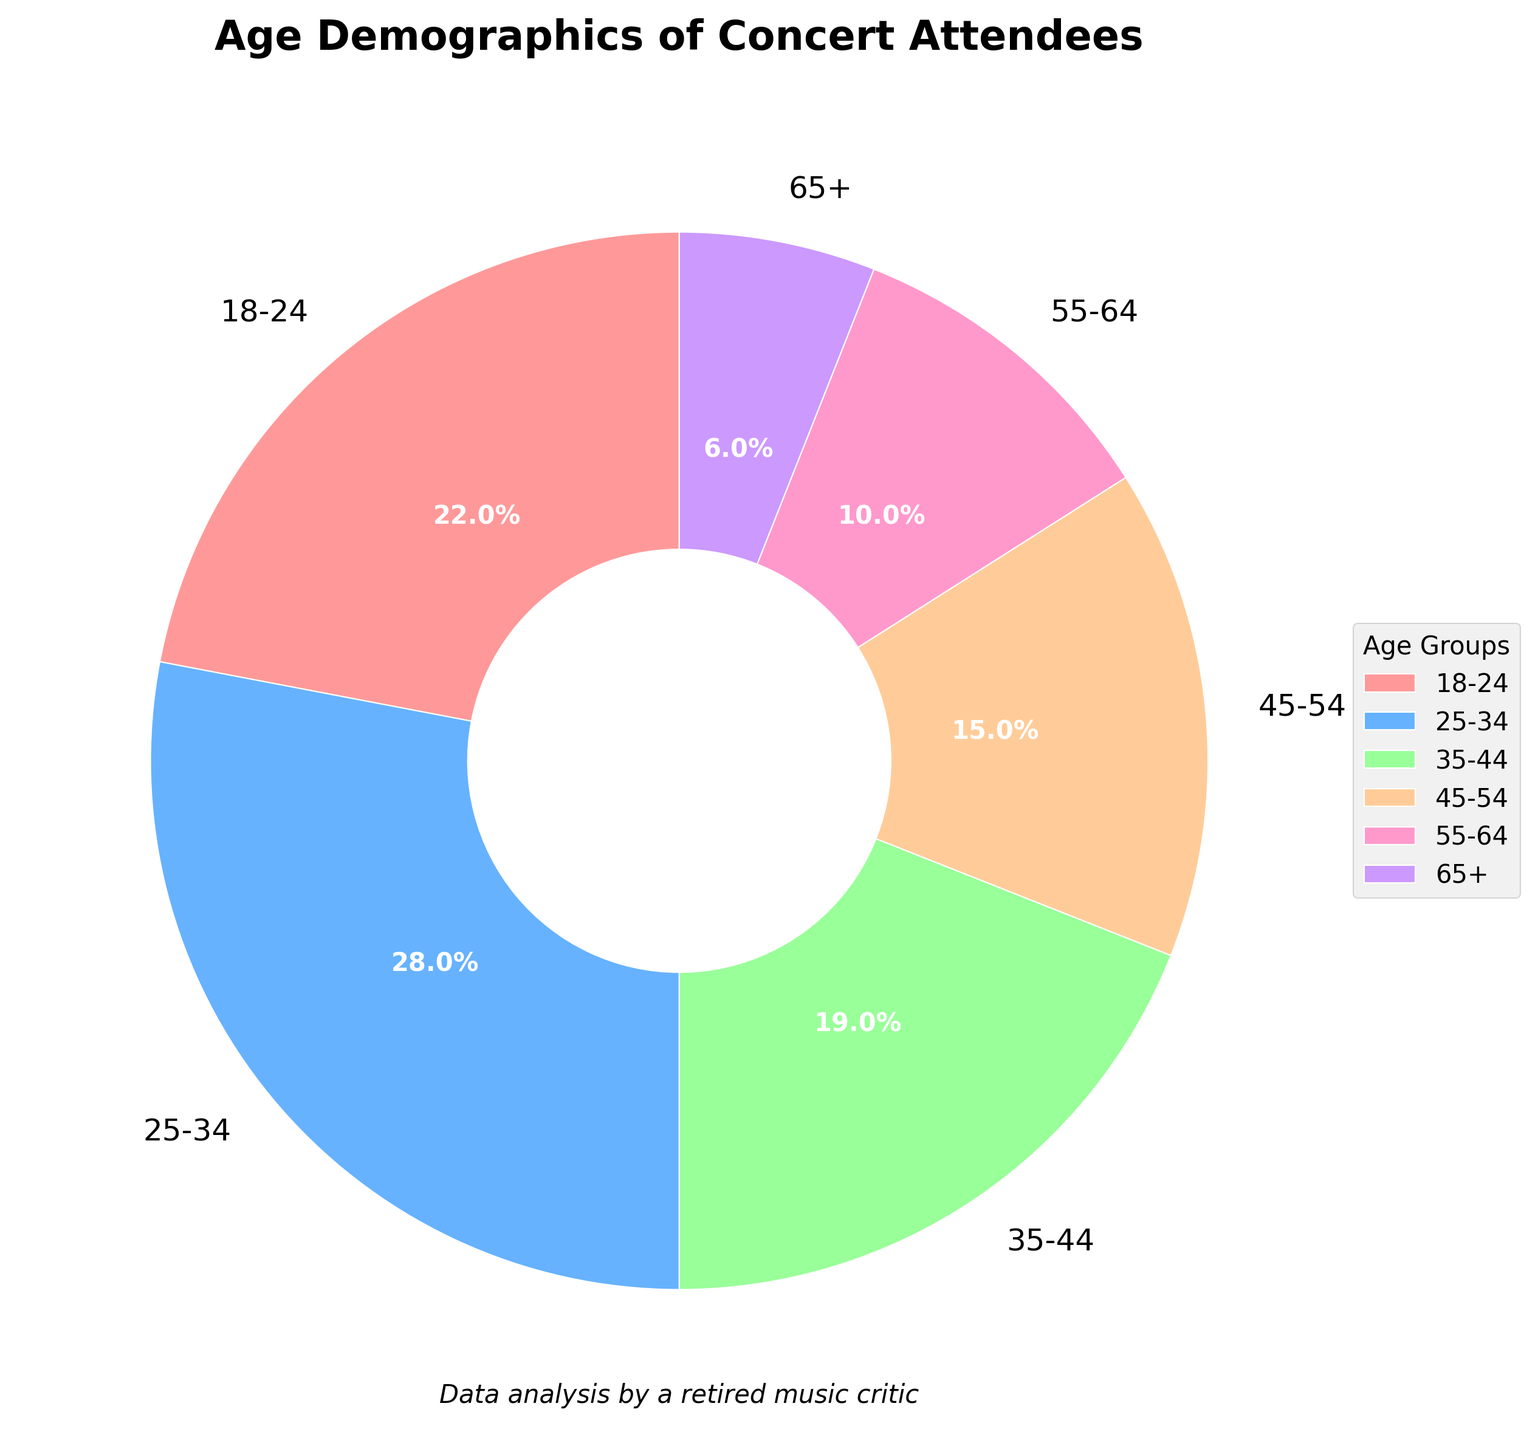Which age group has the highest percentage of concert attendees? The pie chart shows different age groups and their respective percentages. The age group with the highest percentage is represented as the largest segment. From the chart, it is evident that the 25-34 age group has the largest segment.
Answer: 25-34 What is the total percentage of concert attendees aged 35 and older? To find this, sum the percentages of the age groups 35-44, 45-54, 55-64, and 65+. According to the data: 19% + 15% + 10% + 6% = 50%.
Answer: 50% Which age group has the smallest representation at the concerts? The smallest segment in the pie chart corresponds to the age group with the smallest percentage. From the chart, the 65+ age group has the smallest segment.
Answer: 65+ How much higher is the percentage of attendees aged 18-24 compared to those aged 65+? Subtract the percentage of the 65+ age group from the percentage of the 18-24 age group: 22% - 6% = 16%.
Answer: 16% What is the percentage difference between the 25-34 and 45-54 age groups? Subtract the percentage of the 45-54 age group from the percentage of the 25-34 age group: 28% - 15% = 13%.
Answer: 13% What is the sum of the percentages for the two highest age groups? Identify the two age groups with the highest percentages, which are 25-34 (28%) and 18-24 (22%). Add these two percentages: 28% + 22% = 50%.
Answer: 50% How much more popular is the concert among the 25-34 age group compared to the 55-64 age group? Subtract the percentage of the 55-64 age group from the percentage of the 25-34 age group: 28% - 10% = 18%.
Answer: 18% Which two age groups combined make up less than 20% of the audience? Add the percentages of the smallest age groups until the sum is less than 20%. The age groups 65+ (6%) and 55-64 (10%) combined make up 16%, which is less than 20%.
Answer: 65+ and 55-64 By what percentage does the 35-44 age group exceed the 55-64 age group? Subtract the percentage of the 55-64 age group from the percentage of the 35-44 age group: 19% - 10% = 9%.
Answer: 9% What is the combined percentage of the two smallest age groups? Add the percentages of the age groups 55-64 and 65+: 10% + 6% = 16%.
Answer: 16% 